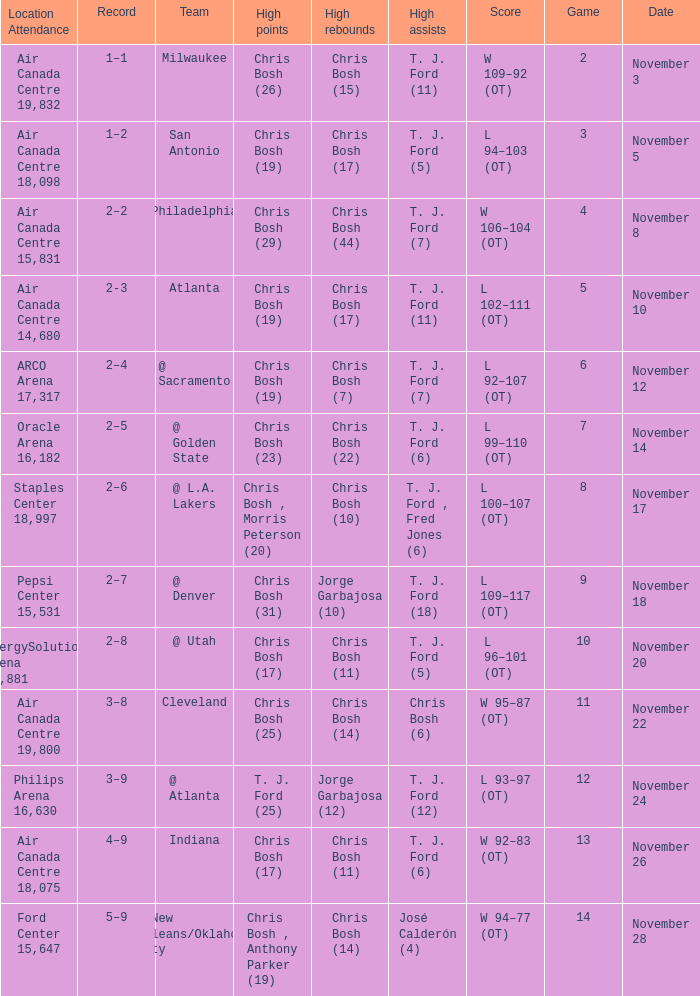What was the score of the game on November 12? L 92–107 (OT). 